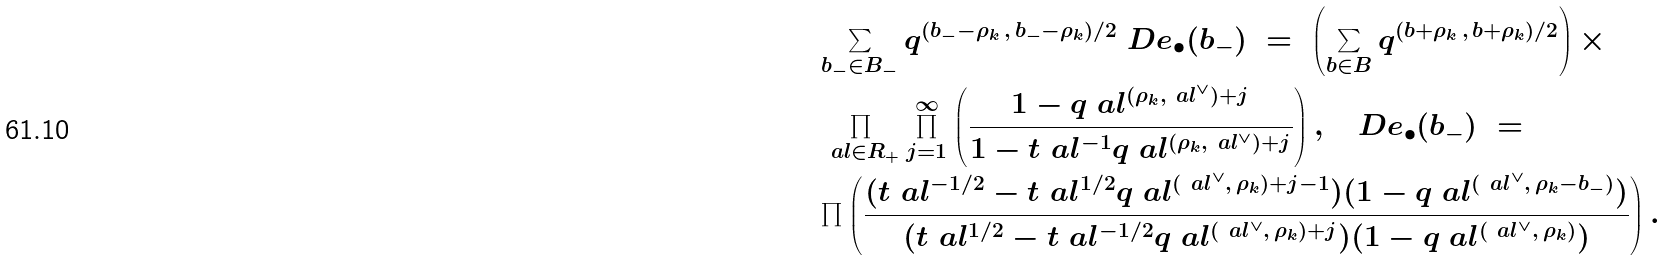Convert formula to latex. <formula><loc_0><loc_0><loc_500><loc_500>& \sum _ { b _ { - } \in B _ { - } } q ^ { ( b _ { - } - \rho _ { k } \, , \, b _ { - } - \rho _ { k } ) / 2 } \ D e _ { \bullet } ( b _ { - } ) \ = \ \left ( \sum _ { b \in B } q ^ { ( b + \rho _ { k } \, , \, b + \rho _ { k } ) / 2 } \right ) \times \\ & \prod _ { \ a l \in R _ { + } } \prod _ { j = 1 } ^ { \infty } \left ( \frac { 1 - q _ { \ } a l ^ { ( \rho _ { k } , \ a l ^ { \vee } ) + j } } { 1 - t _ { \ } a l ^ { - 1 } q _ { \ } a l ^ { ( \rho _ { k } , \ a l ^ { \vee } ) + j } } \right ) , \quad D e _ { \bullet } ( b _ { - } ) \ = \\ & \prod \left ( \frac { ( t _ { \ } a l ^ { - 1 / 2 } - t _ { \ } a l ^ { 1 / 2 } q _ { \ } a l ^ { ( \ a l ^ { \vee } , \, \rho _ { k } ) + j - 1 } ) ( 1 - q _ { \ } a l ^ { ( \ a l ^ { \vee } , \, \rho _ { k } - b _ { - } ) } ) } { ( t _ { \ } a l ^ { 1 / 2 } - t _ { \ } a l ^ { - 1 / 2 } q _ { \ } a l ^ { ( \ a l ^ { \vee } , \, \rho _ { k } ) + j } ) ( 1 - q _ { \ } a l ^ { ( \ a l ^ { \vee } , \, \rho _ { k } ) } ) } \right ) .</formula> 